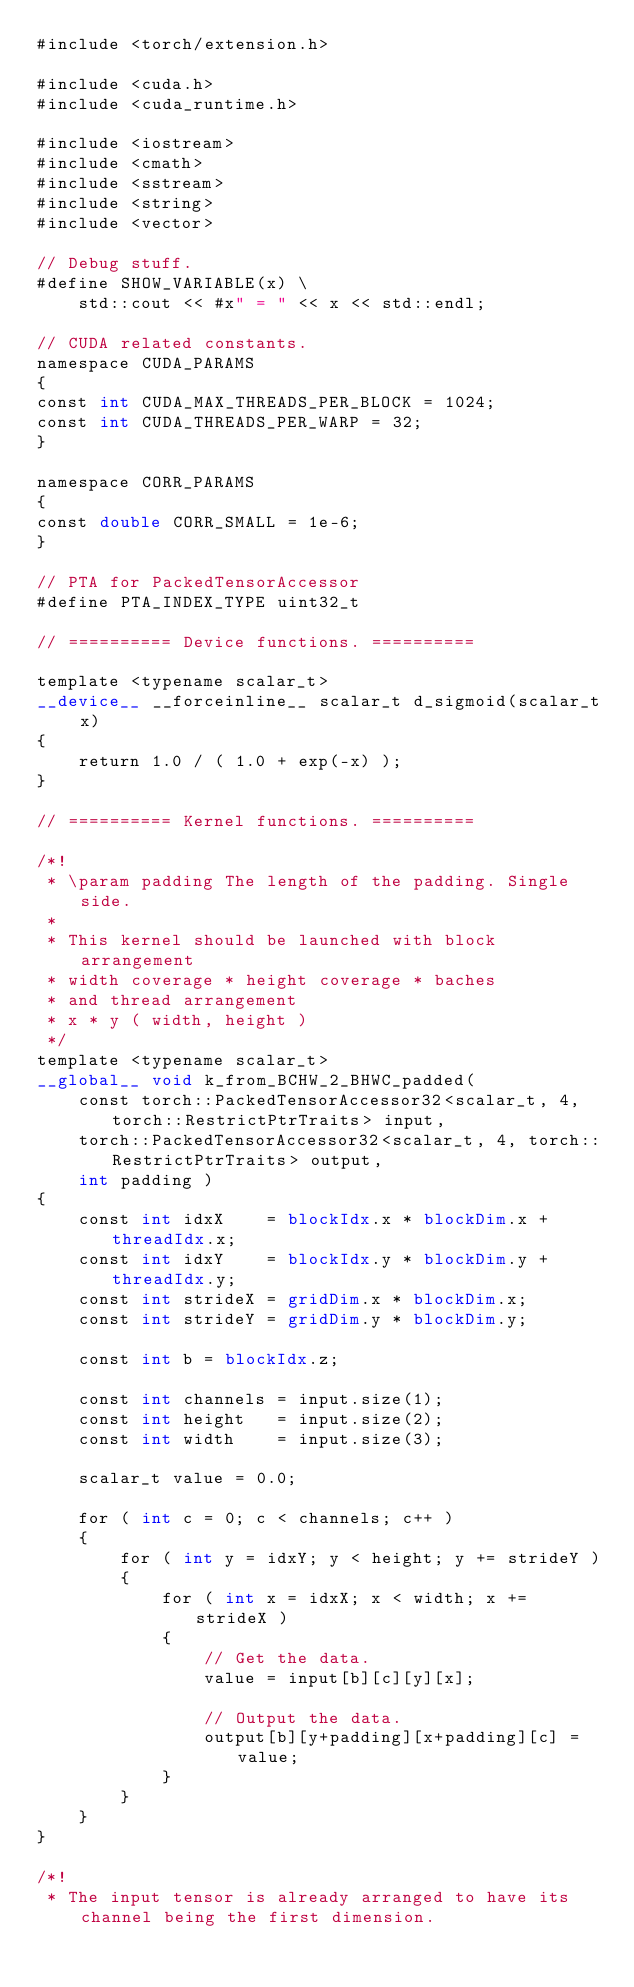Convert code to text. <code><loc_0><loc_0><loc_500><loc_500><_Cuda_>#include <torch/extension.h>

#include <cuda.h>
#include <cuda_runtime.h>

#include <iostream>
#include <cmath>
#include <sstream>
#include <string>
#include <vector>

// Debug stuff.
#define SHOW_VARIABLE(x) \
    std::cout << #x" = " << x << std::endl;

// CUDA related constants.
namespace CUDA_PARAMS
{
const int CUDA_MAX_THREADS_PER_BLOCK = 1024;
const int CUDA_THREADS_PER_WARP = 32;   
}

namespace CORR_PARAMS
{
const double CORR_SMALL = 1e-6;
}

// PTA for PackedTensorAccessor
#define PTA_INDEX_TYPE uint32_t

// ========== Device functions. ==========

template <typename scalar_t> 
__device__ __forceinline__ scalar_t d_sigmoid(scalar_t x)
{
    return 1.0 / ( 1.0 + exp(-x) );
}

// ========== Kernel functions. ==========

/*!
 * \param padding The length of the padding. Single side.
 * 
 * This kernel should be launched with block arrangement
 * width coverage * height coverage * baches
 * and thread arrangement
 * x * y ( width, height )
 */
template <typename scalar_t> 
__global__ void k_from_BCHW_2_BHWC_padded(
    const torch::PackedTensorAccessor32<scalar_t, 4, torch::RestrictPtrTraits> input, 
    torch::PackedTensorAccessor32<scalar_t, 4, torch::RestrictPtrTraits> output,
    int padding )
{
    const int idxX    = blockIdx.x * blockDim.x + threadIdx.x;
    const int idxY    = blockIdx.y * blockDim.y + threadIdx.y;
    const int strideX = gridDim.x * blockDim.x;
    const int strideY = gridDim.y * blockDim.y;

    const int b = blockIdx.z;

    const int channels = input.size(1);
    const int height   = input.size(2);
    const int width    = input.size(3);

    scalar_t value = 0.0;

    for ( int c = 0; c < channels; c++ )
    {
        for ( int y = idxY; y < height; y += strideY )
        {
            for ( int x = idxX; x < width; x += strideX )
            {
                // Get the data.
                value = input[b][c][y][x];

                // Output the data.
                output[b][y+padding][x+padding][c] = value;
            }
        }
    }
}

/*!
 * The input tensor is already arranged to have its channel being the first dimension.</code> 